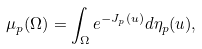Convert formula to latex. <formula><loc_0><loc_0><loc_500><loc_500>\mu _ { p } ( \Omega ) = \int _ { \Omega } e ^ { - J _ { p } ( u ) } d \eta _ { p } ( u ) ,</formula> 